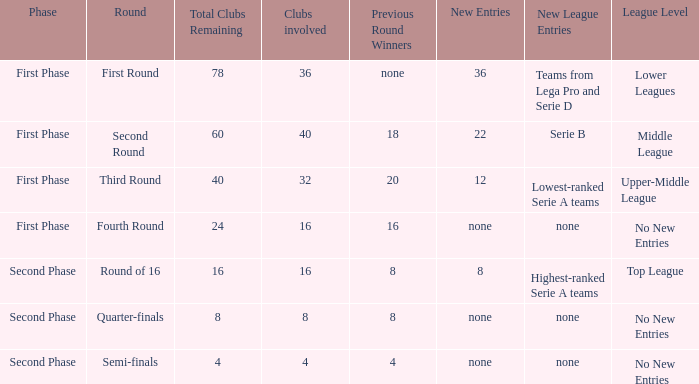At what phase in this round can the presence of 12 new entries be observed? First Phase. Give me the full table as a dictionary. {'header': ['Phase', 'Round', 'Total Clubs Remaining', 'Clubs involved', 'Previous Round Winners', 'New Entries', 'New League Entries', 'League Level'], 'rows': [['First Phase', 'First Round', '78', '36', 'none', '36', 'Teams from Lega Pro and Serie D', 'Lower Leagues'], ['First Phase', 'Second Round', '60', '40', '18', '22', 'Serie B', 'Middle League'], ['First Phase', 'Third Round', '40', '32', '20', '12', 'Lowest-ranked Serie A teams', 'Upper-Middle League'], ['First Phase', 'Fourth Round', '24', '16', '16', 'none', 'none', 'No New Entries'], ['Second Phase', 'Round of 16', '16', '16', '8', '8', 'Highest-ranked Serie A teams', 'Top League'], ['Second Phase', 'Quarter-finals', '8', '8', '8', 'none', 'none', 'No New Entries'], ['Second Phase', 'Semi-finals', '4', '4', '4', 'none', 'none', 'No New Entries']]} 